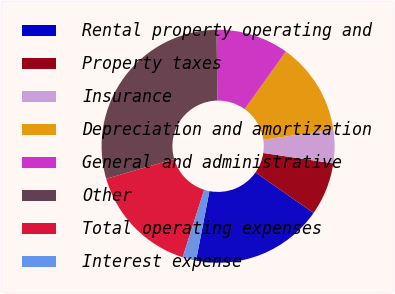Convert chart to OTSL. <chart><loc_0><loc_0><loc_500><loc_500><pie_chart><fcel>Rental property operating and<fcel>Property taxes<fcel>Insurance<fcel>Depreciation and amortization<fcel>General and administrative<fcel>Other<fcel>Total operating expenses<fcel>Interest expense<nl><fcel>18.32%<fcel>7.36%<fcel>4.62%<fcel>12.84%<fcel>10.1%<fcel>29.29%<fcel>15.58%<fcel>1.88%<nl></chart> 